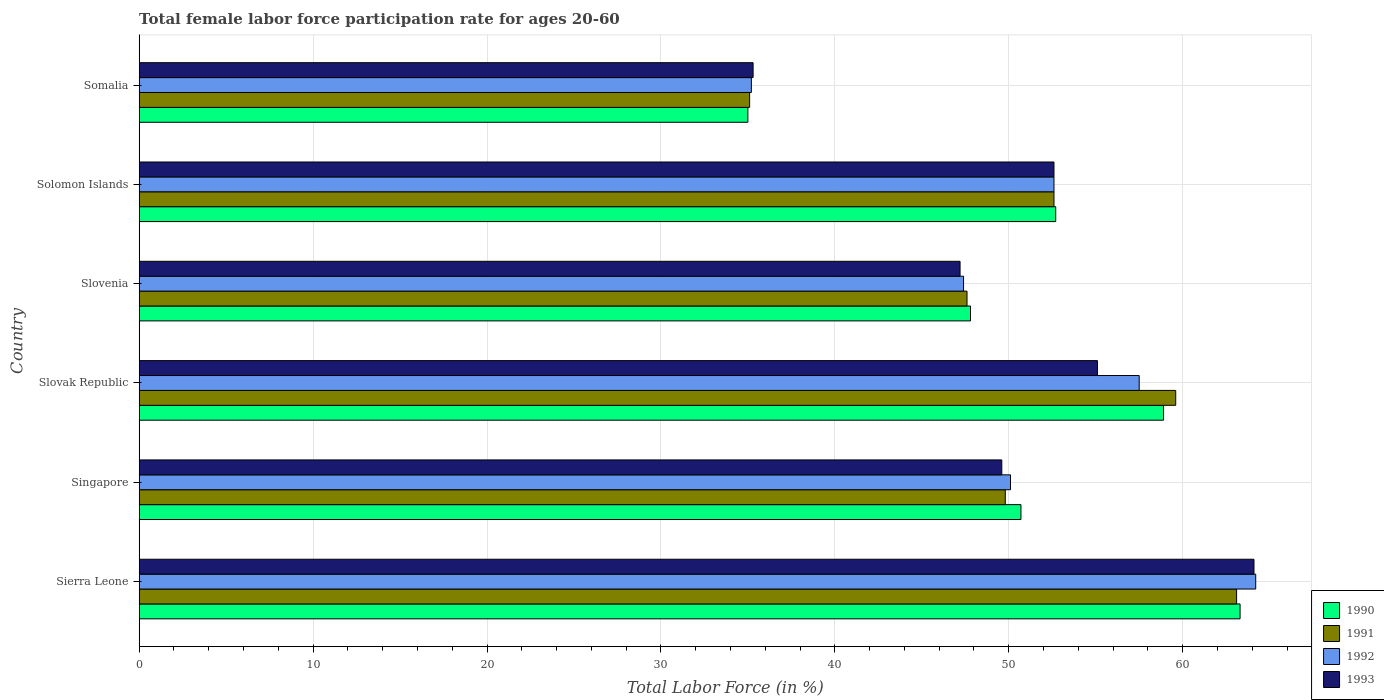How many different coloured bars are there?
Your answer should be very brief. 4. Are the number of bars per tick equal to the number of legend labels?
Make the answer very short. Yes. Are the number of bars on each tick of the Y-axis equal?
Offer a terse response. Yes. How many bars are there on the 2nd tick from the bottom?
Offer a very short reply. 4. What is the label of the 3rd group of bars from the top?
Your response must be concise. Slovenia. What is the female labor force participation rate in 1991 in Singapore?
Keep it short and to the point. 49.8. Across all countries, what is the maximum female labor force participation rate in 1993?
Provide a short and direct response. 64.1. Across all countries, what is the minimum female labor force participation rate in 1990?
Your answer should be very brief. 35. In which country was the female labor force participation rate in 1992 maximum?
Give a very brief answer. Sierra Leone. In which country was the female labor force participation rate in 1993 minimum?
Provide a succinct answer. Somalia. What is the total female labor force participation rate in 1993 in the graph?
Give a very brief answer. 303.9. What is the difference between the female labor force participation rate in 1992 in Slovenia and that in Somalia?
Make the answer very short. 12.2. What is the difference between the female labor force participation rate in 1992 in Slovenia and the female labor force participation rate in 1993 in Slovak Republic?
Provide a succinct answer. -7.7. What is the average female labor force participation rate in 1991 per country?
Ensure brevity in your answer.  51.3. What is the difference between the female labor force participation rate in 1993 and female labor force participation rate in 1991 in Slovenia?
Your answer should be compact. -0.4. What is the ratio of the female labor force participation rate in 1993 in Sierra Leone to that in Slovenia?
Your answer should be compact. 1.36. Is the female labor force participation rate in 1990 in Sierra Leone less than that in Somalia?
Make the answer very short. No. Is the difference between the female labor force participation rate in 1993 in Slovenia and Solomon Islands greater than the difference between the female labor force participation rate in 1991 in Slovenia and Solomon Islands?
Your answer should be very brief. No. What is the difference between the highest and the second highest female labor force participation rate in 1991?
Provide a short and direct response. 3.5. What is the difference between the highest and the lowest female labor force participation rate in 1992?
Give a very brief answer. 29. Is it the case that in every country, the sum of the female labor force participation rate in 1992 and female labor force participation rate in 1990 is greater than the sum of female labor force participation rate in 1991 and female labor force participation rate in 1993?
Offer a terse response. No. What does the 4th bar from the bottom in Slovak Republic represents?
Your answer should be very brief. 1993. Are all the bars in the graph horizontal?
Provide a short and direct response. Yes. How many countries are there in the graph?
Offer a very short reply. 6. What is the difference between two consecutive major ticks on the X-axis?
Your response must be concise. 10. Where does the legend appear in the graph?
Make the answer very short. Bottom right. How many legend labels are there?
Your response must be concise. 4. How are the legend labels stacked?
Provide a succinct answer. Vertical. What is the title of the graph?
Your answer should be compact. Total female labor force participation rate for ages 20-60. Does "1982" appear as one of the legend labels in the graph?
Provide a succinct answer. No. What is the label or title of the X-axis?
Give a very brief answer. Total Labor Force (in %). What is the label or title of the Y-axis?
Offer a very short reply. Country. What is the Total Labor Force (in %) in 1990 in Sierra Leone?
Give a very brief answer. 63.3. What is the Total Labor Force (in %) in 1991 in Sierra Leone?
Offer a very short reply. 63.1. What is the Total Labor Force (in %) of 1992 in Sierra Leone?
Make the answer very short. 64.2. What is the Total Labor Force (in %) in 1993 in Sierra Leone?
Your response must be concise. 64.1. What is the Total Labor Force (in %) in 1990 in Singapore?
Offer a very short reply. 50.7. What is the Total Labor Force (in %) in 1991 in Singapore?
Give a very brief answer. 49.8. What is the Total Labor Force (in %) in 1992 in Singapore?
Your answer should be compact. 50.1. What is the Total Labor Force (in %) in 1993 in Singapore?
Your answer should be compact. 49.6. What is the Total Labor Force (in %) in 1990 in Slovak Republic?
Your answer should be compact. 58.9. What is the Total Labor Force (in %) of 1991 in Slovak Republic?
Your answer should be very brief. 59.6. What is the Total Labor Force (in %) in 1992 in Slovak Republic?
Ensure brevity in your answer.  57.5. What is the Total Labor Force (in %) in 1993 in Slovak Republic?
Your answer should be very brief. 55.1. What is the Total Labor Force (in %) of 1990 in Slovenia?
Offer a terse response. 47.8. What is the Total Labor Force (in %) in 1991 in Slovenia?
Keep it short and to the point. 47.6. What is the Total Labor Force (in %) of 1992 in Slovenia?
Keep it short and to the point. 47.4. What is the Total Labor Force (in %) of 1993 in Slovenia?
Your answer should be very brief. 47.2. What is the Total Labor Force (in %) of 1990 in Solomon Islands?
Keep it short and to the point. 52.7. What is the Total Labor Force (in %) of 1991 in Solomon Islands?
Offer a terse response. 52.6. What is the Total Labor Force (in %) of 1992 in Solomon Islands?
Make the answer very short. 52.6. What is the Total Labor Force (in %) of 1993 in Solomon Islands?
Make the answer very short. 52.6. What is the Total Labor Force (in %) of 1991 in Somalia?
Ensure brevity in your answer.  35.1. What is the Total Labor Force (in %) in 1992 in Somalia?
Provide a succinct answer. 35.2. What is the Total Labor Force (in %) in 1993 in Somalia?
Your answer should be compact. 35.3. Across all countries, what is the maximum Total Labor Force (in %) in 1990?
Provide a short and direct response. 63.3. Across all countries, what is the maximum Total Labor Force (in %) of 1991?
Provide a succinct answer. 63.1. Across all countries, what is the maximum Total Labor Force (in %) of 1992?
Your answer should be very brief. 64.2. Across all countries, what is the maximum Total Labor Force (in %) of 1993?
Provide a short and direct response. 64.1. Across all countries, what is the minimum Total Labor Force (in %) in 1991?
Provide a succinct answer. 35.1. Across all countries, what is the minimum Total Labor Force (in %) of 1992?
Ensure brevity in your answer.  35.2. Across all countries, what is the minimum Total Labor Force (in %) in 1993?
Ensure brevity in your answer.  35.3. What is the total Total Labor Force (in %) of 1990 in the graph?
Offer a very short reply. 308.4. What is the total Total Labor Force (in %) of 1991 in the graph?
Ensure brevity in your answer.  307.8. What is the total Total Labor Force (in %) of 1992 in the graph?
Your answer should be compact. 307. What is the total Total Labor Force (in %) of 1993 in the graph?
Give a very brief answer. 303.9. What is the difference between the Total Labor Force (in %) in 1991 in Sierra Leone and that in Singapore?
Offer a very short reply. 13.3. What is the difference between the Total Labor Force (in %) in 1992 in Sierra Leone and that in Singapore?
Your response must be concise. 14.1. What is the difference between the Total Labor Force (in %) in 1993 in Sierra Leone and that in Singapore?
Your response must be concise. 14.5. What is the difference between the Total Labor Force (in %) of 1991 in Sierra Leone and that in Slovak Republic?
Ensure brevity in your answer.  3.5. What is the difference between the Total Labor Force (in %) in 1993 in Sierra Leone and that in Slovak Republic?
Your response must be concise. 9. What is the difference between the Total Labor Force (in %) of 1991 in Sierra Leone and that in Slovenia?
Offer a very short reply. 15.5. What is the difference between the Total Labor Force (in %) of 1992 in Sierra Leone and that in Slovenia?
Your answer should be very brief. 16.8. What is the difference between the Total Labor Force (in %) of 1993 in Sierra Leone and that in Slovenia?
Give a very brief answer. 16.9. What is the difference between the Total Labor Force (in %) in 1990 in Sierra Leone and that in Solomon Islands?
Offer a terse response. 10.6. What is the difference between the Total Labor Force (in %) of 1993 in Sierra Leone and that in Solomon Islands?
Ensure brevity in your answer.  11.5. What is the difference between the Total Labor Force (in %) of 1990 in Sierra Leone and that in Somalia?
Your answer should be very brief. 28.3. What is the difference between the Total Labor Force (in %) in 1993 in Sierra Leone and that in Somalia?
Give a very brief answer. 28.8. What is the difference between the Total Labor Force (in %) in 1990 in Singapore and that in Slovak Republic?
Keep it short and to the point. -8.2. What is the difference between the Total Labor Force (in %) of 1992 in Singapore and that in Slovak Republic?
Offer a very short reply. -7.4. What is the difference between the Total Labor Force (in %) of 1993 in Singapore and that in Slovak Republic?
Your answer should be compact. -5.5. What is the difference between the Total Labor Force (in %) in 1990 in Singapore and that in Slovenia?
Keep it short and to the point. 2.9. What is the difference between the Total Labor Force (in %) of 1991 in Singapore and that in Slovenia?
Keep it short and to the point. 2.2. What is the difference between the Total Labor Force (in %) in 1992 in Singapore and that in Slovenia?
Provide a succinct answer. 2.7. What is the difference between the Total Labor Force (in %) of 1993 in Singapore and that in Slovenia?
Ensure brevity in your answer.  2.4. What is the difference between the Total Labor Force (in %) of 1993 in Singapore and that in Solomon Islands?
Keep it short and to the point. -3. What is the difference between the Total Labor Force (in %) of 1991 in Singapore and that in Somalia?
Ensure brevity in your answer.  14.7. What is the difference between the Total Labor Force (in %) in 1992 in Singapore and that in Somalia?
Offer a very short reply. 14.9. What is the difference between the Total Labor Force (in %) of 1993 in Singapore and that in Somalia?
Provide a succinct answer. 14.3. What is the difference between the Total Labor Force (in %) of 1991 in Slovak Republic and that in Slovenia?
Offer a terse response. 12. What is the difference between the Total Labor Force (in %) in 1991 in Slovak Republic and that in Solomon Islands?
Make the answer very short. 7. What is the difference between the Total Labor Force (in %) in 1990 in Slovak Republic and that in Somalia?
Offer a very short reply. 23.9. What is the difference between the Total Labor Force (in %) in 1991 in Slovak Republic and that in Somalia?
Provide a short and direct response. 24.5. What is the difference between the Total Labor Force (in %) of 1992 in Slovak Republic and that in Somalia?
Offer a terse response. 22.3. What is the difference between the Total Labor Force (in %) of 1993 in Slovak Republic and that in Somalia?
Your answer should be very brief. 19.8. What is the difference between the Total Labor Force (in %) in 1992 in Slovenia and that in Solomon Islands?
Keep it short and to the point. -5.2. What is the difference between the Total Labor Force (in %) in 1993 in Slovenia and that in Solomon Islands?
Keep it short and to the point. -5.4. What is the difference between the Total Labor Force (in %) of 1991 in Slovenia and that in Somalia?
Make the answer very short. 12.5. What is the difference between the Total Labor Force (in %) of 1992 in Slovenia and that in Somalia?
Provide a succinct answer. 12.2. What is the difference between the Total Labor Force (in %) in 1993 in Slovenia and that in Somalia?
Provide a short and direct response. 11.9. What is the difference between the Total Labor Force (in %) of 1990 in Solomon Islands and that in Somalia?
Provide a succinct answer. 17.7. What is the difference between the Total Labor Force (in %) of 1991 in Solomon Islands and that in Somalia?
Offer a very short reply. 17.5. What is the difference between the Total Labor Force (in %) of 1993 in Solomon Islands and that in Somalia?
Make the answer very short. 17.3. What is the difference between the Total Labor Force (in %) of 1990 in Sierra Leone and the Total Labor Force (in %) of 1991 in Singapore?
Give a very brief answer. 13.5. What is the difference between the Total Labor Force (in %) in 1991 in Sierra Leone and the Total Labor Force (in %) in 1993 in Singapore?
Provide a succinct answer. 13.5. What is the difference between the Total Labor Force (in %) of 1992 in Sierra Leone and the Total Labor Force (in %) of 1993 in Singapore?
Provide a succinct answer. 14.6. What is the difference between the Total Labor Force (in %) in 1990 in Sierra Leone and the Total Labor Force (in %) in 1992 in Slovak Republic?
Offer a terse response. 5.8. What is the difference between the Total Labor Force (in %) in 1990 in Sierra Leone and the Total Labor Force (in %) in 1993 in Slovak Republic?
Provide a short and direct response. 8.2. What is the difference between the Total Labor Force (in %) of 1991 in Sierra Leone and the Total Labor Force (in %) of 1992 in Slovak Republic?
Give a very brief answer. 5.6. What is the difference between the Total Labor Force (in %) of 1991 in Sierra Leone and the Total Labor Force (in %) of 1993 in Slovak Republic?
Your answer should be very brief. 8. What is the difference between the Total Labor Force (in %) of 1990 in Sierra Leone and the Total Labor Force (in %) of 1992 in Slovenia?
Keep it short and to the point. 15.9. What is the difference between the Total Labor Force (in %) of 1992 in Sierra Leone and the Total Labor Force (in %) of 1993 in Slovenia?
Keep it short and to the point. 17. What is the difference between the Total Labor Force (in %) of 1990 in Sierra Leone and the Total Labor Force (in %) of 1991 in Solomon Islands?
Provide a short and direct response. 10.7. What is the difference between the Total Labor Force (in %) of 1991 in Sierra Leone and the Total Labor Force (in %) of 1992 in Solomon Islands?
Provide a succinct answer. 10.5. What is the difference between the Total Labor Force (in %) of 1991 in Sierra Leone and the Total Labor Force (in %) of 1993 in Solomon Islands?
Ensure brevity in your answer.  10.5. What is the difference between the Total Labor Force (in %) of 1992 in Sierra Leone and the Total Labor Force (in %) of 1993 in Solomon Islands?
Your answer should be compact. 11.6. What is the difference between the Total Labor Force (in %) in 1990 in Sierra Leone and the Total Labor Force (in %) in 1991 in Somalia?
Keep it short and to the point. 28.2. What is the difference between the Total Labor Force (in %) of 1990 in Sierra Leone and the Total Labor Force (in %) of 1992 in Somalia?
Your answer should be very brief. 28.1. What is the difference between the Total Labor Force (in %) of 1990 in Sierra Leone and the Total Labor Force (in %) of 1993 in Somalia?
Your answer should be compact. 28. What is the difference between the Total Labor Force (in %) of 1991 in Sierra Leone and the Total Labor Force (in %) of 1992 in Somalia?
Provide a short and direct response. 27.9. What is the difference between the Total Labor Force (in %) in 1991 in Sierra Leone and the Total Labor Force (in %) in 1993 in Somalia?
Your answer should be compact. 27.8. What is the difference between the Total Labor Force (in %) in 1992 in Sierra Leone and the Total Labor Force (in %) in 1993 in Somalia?
Give a very brief answer. 28.9. What is the difference between the Total Labor Force (in %) in 1990 in Singapore and the Total Labor Force (in %) in 1992 in Slovak Republic?
Keep it short and to the point. -6.8. What is the difference between the Total Labor Force (in %) in 1991 in Singapore and the Total Labor Force (in %) in 1993 in Slovak Republic?
Give a very brief answer. -5.3. What is the difference between the Total Labor Force (in %) of 1991 in Singapore and the Total Labor Force (in %) of 1993 in Slovenia?
Provide a succinct answer. 2.6. What is the difference between the Total Labor Force (in %) in 1990 in Singapore and the Total Labor Force (in %) in 1993 in Solomon Islands?
Ensure brevity in your answer.  -1.9. What is the difference between the Total Labor Force (in %) of 1991 in Singapore and the Total Labor Force (in %) of 1992 in Solomon Islands?
Provide a short and direct response. -2.8. What is the difference between the Total Labor Force (in %) of 1991 in Singapore and the Total Labor Force (in %) of 1993 in Solomon Islands?
Your answer should be very brief. -2.8. What is the difference between the Total Labor Force (in %) in 1992 in Singapore and the Total Labor Force (in %) in 1993 in Solomon Islands?
Ensure brevity in your answer.  -2.5. What is the difference between the Total Labor Force (in %) in 1990 in Singapore and the Total Labor Force (in %) in 1991 in Somalia?
Make the answer very short. 15.6. What is the difference between the Total Labor Force (in %) in 1992 in Singapore and the Total Labor Force (in %) in 1993 in Somalia?
Offer a terse response. 14.8. What is the difference between the Total Labor Force (in %) in 1990 in Slovak Republic and the Total Labor Force (in %) in 1992 in Slovenia?
Your answer should be compact. 11.5. What is the difference between the Total Labor Force (in %) in 1990 in Slovak Republic and the Total Labor Force (in %) in 1993 in Slovenia?
Ensure brevity in your answer.  11.7. What is the difference between the Total Labor Force (in %) in 1991 in Slovak Republic and the Total Labor Force (in %) in 1993 in Slovenia?
Provide a succinct answer. 12.4. What is the difference between the Total Labor Force (in %) of 1990 in Slovak Republic and the Total Labor Force (in %) of 1991 in Solomon Islands?
Ensure brevity in your answer.  6.3. What is the difference between the Total Labor Force (in %) of 1990 in Slovak Republic and the Total Labor Force (in %) of 1992 in Solomon Islands?
Offer a terse response. 6.3. What is the difference between the Total Labor Force (in %) in 1990 in Slovak Republic and the Total Labor Force (in %) in 1993 in Solomon Islands?
Offer a terse response. 6.3. What is the difference between the Total Labor Force (in %) of 1991 in Slovak Republic and the Total Labor Force (in %) of 1992 in Solomon Islands?
Your answer should be compact. 7. What is the difference between the Total Labor Force (in %) of 1991 in Slovak Republic and the Total Labor Force (in %) of 1993 in Solomon Islands?
Your response must be concise. 7. What is the difference between the Total Labor Force (in %) of 1992 in Slovak Republic and the Total Labor Force (in %) of 1993 in Solomon Islands?
Provide a short and direct response. 4.9. What is the difference between the Total Labor Force (in %) in 1990 in Slovak Republic and the Total Labor Force (in %) in 1991 in Somalia?
Offer a terse response. 23.8. What is the difference between the Total Labor Force (in %) in 1990 in Slovak Republic and the Total Labor Force (in %) in 1992 in Somalia?
Provide a short and direct response. 23.7. What is the difference between the Total Labor Force (in %) in 1990 in Slovak Republic and the Total Labor Force (in %) in 1993 in Somalia?
Give a very brief answer. 23.6. What is the difference between the Total Labor Force (in %) in 1991 in Slovak Republic and the Total Labor Force (in %) in 1992 in Somalia?
Ensure brevity in your answer.  24.4. What is the difference between the Total Labor Force (in %) in 1991 in Slovak Republic and the Total Labor Force (in %) in 1993 in Somalia?
Keep it short and to the point. 24.3. What is the difference between the Total Labor Force (in %) of 1992 in Slovak Republic and the Total Labor Force (in %) of 1993 in Somalia?
Offer a terse response. 22.2. What is the difference between the Total Labor Force (in %) of 1990 in Slovenia and the Total Labor Force (in %) of 1991 in Solomon Islands?
Your answer should be very brief. -4.8. What is the difference between the Total Labor Force (in %) of 1991 in Slovenia and the Total Labor Force (in %) of 1992 in Solomon Islands?
Your response must be concise. -5. What is the difference between the Total Labor Force (in %) of 1990 in Slovenia and the Total Labor Force (in %) of 1993 in Somalia?
Your answer should be compact. 12.5. What is the difference between the Total Labor Force (in %) of 1991 in Slovenia and the Total Labor Force (in %) of 1993 in Somalia?
Offer a very short reply. 12.3. What is the difference between the Total Labor Force (in %) of 1990 in Solomon Islands and the Total Labor Force (in %) of 1991 in Somalia?
Make the answer very short. 17.6. What is the difference between the Total Labor Force (in %) in 1990 in Solomon Islands and the Total Labor Force (in %) in 1993 in Somalia?
Provide a succinct answer. 17.4. What is the difference between the Total Labor Force (in %) of 1991 in Solomon Islands and the Total Labor Force (in %) of 1992 in Somalia?
Ensure brevity in your answer.  17.4. What is the difference between the Total Labor Force (in %) of 1991 in Solomon Islands and the Total Labor Force (in %) of 1993 in Somalia?
Your answer should be compact. 17.3. What is the difference between the Total Labor Force (in %) in 1992 in Solomon Islands and the Total Labor Force (in %) in 1993 in Somalia?
Keep it short and to the point. 17.3. What is the average Total Labor Force (in %) of 1990 per country?
Your answer should be very brief. 51.4. What is the average Total Labor Force (in %) of 1991 per country?
Make the answer very short. 51.3. What is the average Total Labor Force (in %) of 1992 per country?
Keep it short and to the point. 51.17. What is the average Total Labor Force (in %) of 1993 per country?
Your answer should be compact. 50.65. What is the difference between the Total Labor Force (in %) in 1990 and Total Labor Force (in %) in 1991 in Sierra Leone?
Offer a terse response. 0.2. What is the difference between the Total Labor Force (in %) of 1990 and Total Labor Force (in %) of 1992 in Sierra Leone?
Provide a succinct answer. -0.9. What is the difference between the Total Labor Force (in %) of 1990 and Total Labor Force (in %) of 1993 in Sierra Leone?
Provide a short and direct response. -0.8. What is the difference between the Total Labor Force (in %) of 1991 and Total Labor Force (in %) of 1992 in Sierra Leone?
Give a very brief answer. -1.1. What is the difference between the Total Labor Force (in %) in 1991 and Total Labor Force (in %) in 1993 in Sierra Leone?
Give a very brief answer. -1. What is the difference between the Total Labor Force (in %) in 1990 and Total Labor Force (in %) in 1991 in Singapore?
Ensure brevity in your answer.  0.9. What is the difference between the Total Labor Force (in %) of 1990 and Total Labor Force (in %) of 1992 in Singapore?
Ensure brevity in your answer.  0.6. What is the difference between the Total Labor Force (in %) of 1990 and Total Labor Force (in %) of 1993 in Singapore?
Offer a terse response. 1.1. What is the difference between the Total Labor Force (in %) of 1990 and Total Labor Force (in %) of 1991 in Slovak Republic?
Your response must be concise. -0.7. What is the difference between the Total Labor Force (in %) of 1991 and Total Labor Force (in %) of 1992 in Slovak Republic?
Offer a very short reply. 2.1. What is the difference between the Total Labor Force (in %) of 1990 and Total Labor Force (in %) of 1991 in Slovenia?
Offer a very short reply. 0.2. What is the difference between the Total Labor Force (in %) in 1990 and Total Labor Force (in %) in 1993 in Slovenia?
Provide a short and direct response. 0.6. What is the difference between the Total Labor Force (in %) of 1990 and Total Labor Force (in %) of 1991 in Solomon Islands?
Your answer should be compact. 0.1. What is the difference between the Total Labor Force (in %) of 1990 and Total Labor Force (in %) of 1993 in Solomon Islands?
Offer a very short reply. 0.1. What is the difference between the Total Labor Force (in %) in 1991 and Total Labor Force (in %) in 1993 in Solomon Islands?
Provide a succinct answer. 0. What is the difference between the Total Labor Force (in %) in 1990 and Total Labor Force (in %) in 1991 in Somalia?
Provide a succinct answer. -0.1. What is the difference between the Total Labor Force (in %) of 1990 and Total Labor Force (in %) of 1993 in Somalia?
Offer a terse response. -0.3. What is the difference between the Total Labor Force (in %) of 1991 and Total Labor Force (in %) of 1993 in Somalia?
Give a very brief answer. -0.2. What is the difference between the Total Labor Force (in %) in 1992 and Total Labor Force (in %) in 1993 in Somalia?
Make the answer very short. -0.1. What is the ratio of the Total Labor Force (in %) of 1990 in Sierra Leone to that in Singapore?
Your answer should be compact. 1.25. What is the ratio of the Total Labor Force (in %) in 1991 in Sierra Leone to that in Singapore?
Offer a very short reply. 1.27. What is the ratio of the Total Labor Force (in %) in 1992 in Sierra Leone to that in Singapore?
Offer a very short reply. 1.28. What is the ratio of the Total Labor Force (in %) in 1993 in Sierra Leone to that in Singapore?
Your answer should be very brief. 1.29. What is the ratio of the Total Labor Force (in %) in 1990 in Sierra Leone to that in Slovak Republic?
Ensure brevity in your answer.  1.07. What is the ratio of the Total Labor Force (in %) in 1991 in Sierra Leone to that in Slovak Republic?
Your answer should be very brief. 1.06. What is the ratio of the Total Labor Force (in %) in 1992 in Sierra Leone to that in Slovak Republic?
Provide a succinct answer. 1.12. What is the ratio of the Total Labor Force (in %) in 1993 in Sierra Leone to that in Slovak Republic?
Keep it short and to the point. 1.16. What is the ratio of the Total Labor Force (in %) of 1990 in Sierra Leone to that in Slovenia?
Offer a terse response. 1.32. What is the ratio of the Total Labor Force (in %) in 1991 in Sierra Leone to that in Slovenia?
Provide a short and direct response. 1.33. What is the ratio of the Total Labor Force (in %) in 1992 in Sierra Leone to that in Slovenia?
Provide a short and direct response. 1.35. What is the ratio of the Total Labor Force (in %) in 1993 in Sierra Leone to that in Slovenia?
Provide a short and direct response. 1.36. What is the ratio of the Total Labor Force (in %) in 1990 in Sierra Leone to that in Solomon Islands?
Give a very brief answer. 1.2. What is the ratio of the Total Labor Force (in %) in 1991 in Sierra Leone to that in Solomon Islands?
Give a very brief answer. 1.2. What is the ratio of the Total Labor Force (in %) of 1992 in Sierra Leone to that in Solomon Islands?
Ensure brevity in your answer.  1.22. What is the ratio of the Total Labor Force (in %) of 1993 in Sierra Leone to that in Solomon Islands?
Your answer should be compact. 1.22. What is the ratio of the Total Labor Force (in %) in 1990 in Sierra Leone to that in Somalia?
Provide a succinct answer. 1.81. What is the ratio of the Total Labor Force (in %) of 1991 in Sierra Leone to that in Somalia?
Your answer should be very brief. 1.8. What is the ratio of the Total Labor Force (in %) in 1992 in Sierra Leone to that in Somalia?
Provide a succinct answer. 1.82. What is the ratio of the Total Labor Force (in %) in 1993 in Sierra Leone to that in Somalia?
Ensure brevity in your answer.  1.82. What is the ratio of the Total Labor Force (in %) in 1990 in Singapore to that in Slovak Republic?
Your answer should be compact. 0.86. What is the ratio of the Total Labor Force (in %) of 1991 in Singapore to that in Slovak Republic?
Your response must be concise. 0.84. What is the ratio of the Total Labor Force (in %) in 1992 in Singapore to that in Slovak Republic?
Make the answer very short. 0.87. What is the ratio of the Total Labor Force (in %) of 1993 in Singapore to that in Slovak Republic?
Offer a very short reply. 0.9. What is the ratio of the Total Labor Force (in %) of 1990 in Singapore to that in Slovenia?
Offer a very short reply. 1.06. What is the ratio of the Total Labor Force (in %) in 1991 in Singapore to that in Slovenia?
Your answer should be compact. 1.05. What is the ratio of the Total Labor Force (in %) of 1992 in Singapore to that in Slovenia?
Keep it short and to the point. 1.06. What is the ratio of the Total Labor Force (in %) of 1993 in Singapore to that in Slovenia?
Offer a terse response. 1.05. What is the ratio of the Total Labor Force (in %) of 1991 in Singapore to that in Solomon Islands?
Your response must be concise. 0.95. What is the ratio of the Total Labor Force (in %) in 1992 in Singapore to that in Solomon Islands?
Keep it short and to the point. 0.95. What is the ratio of the Total Labor Force (in %) in 1993 in Singapore to that in Solomon Islands?
Ensure brevity in your answer.  0.94. What is the ratio of the Total Labor Force (in %) of 1990 in Singapore to that in Somalia?
Your response must be concise. 1.45. What is the ratio of the Total Labor Force (in %) in 1991 in Singapore to that in Somalia?
Your answer should be very brief. 1.42. What is the ratio of the Total Labor Force (in %) in 1992 in Singapore to that in Somalia?
Give a very brief answer. 1.42. What is the ratio of the Total Labor Force (in %) of 1993 in Singapore to that in Somalia?
Give a very brief answer. 1.41. What is the ratio of the Total Labor Force (in %) of 1990 in Slovak Republic to that in Slovenia?
Your response must be concise. 1.23. What is the ratio of the Total Labor Force (in %) in 1991 in Slovak Republic to that in Slovenia?
Your answer should be compact. 1.25. What is the ratio of the Total Labor Force (in %) in 1992 in Slovak Republic to that in Slovenia?
Offer a terse response. 1.21. What is the ratio of the Total Labor Force (in %) of 1993 in Slovak Republic to that in Slovenia?
Your answer should be very brief. 1.17. What is the ratio of the Total Labor Force (in %) in 1990 in Slovak Republic to that in Solomon Islands?
Provide a short and direct response. 1.12. What is the ratio of the Total Labor Force (in %) of 1991 in Slovak Republic to that in Solomon Islands?
Offer a very short reply. 1.13. What is the ratio of the Total Labor Force (in %) in 1992 in Slovak Republic to that in Solomon Islands?
Ensure brevity in your answer.  1.09. What is the ratio of the Total Labor Force (in %) of 1993 in Slovak Republic to that in Solomon Islands?
Your answer should be compact. 1.05. What is the ratio of the Total Labor Force (in %) in 1990 in Slovak Republic to that in Somalia?
Provide a succinct answer. 1.68. What is the ratio of the Total Labor Force (in %) of 1991 in Slovak Republic to that in Somalia?
Your answer should be very brief. 1.7. What is the ratio of the Total Labor Force (in %) in 1992 in Slovak Republic to that in Somalia?
Offer a terse response. 1.63. What is the ratio of the Total Labor Force (in %) of 1993 in Slovak Republic to that in Somalia?
Keep it short and to the point. 1.56. What is the ratio of the Total Labor Force (in %) of 1990 in Slovenia to that in Solomon Islands?
Make the answer very short. 0.91. What is the ratio of the Total Labor Force (in %) in 1991 in Slovenia to that in Solomon Islands?
Keep it short and to the point. 0.9. What is the ratio of the Total Labor Force (in %) in 1992 in Slovenia to that in Solomon Islands?
Your response must be concise. 0.9. What is the ratio of the Total Labor Force (in %) of 1993 in Slovenia to that in Solomon Islands?
Your answer should be compact. 0.9. What is the ratio of the Total Labor Force (in %) of 1990 in Slovenia to that in Somalia?
Ensure brevity in your answer.  1.37. What is the ratio of the Total Labor Force (in %) of 1991 in Slovenia to that in Somalia?
Your answer should be very brief. 1.36. What is the ratio of the Total Labor Force (in %) in 1992 in Slovenia to that in Somalia?
Provide a short and direct response. 1.35. What is the ratio of the Total Labor Force (in %) in 1993 in Slovenia to that in Somalia?
Ensure brevity in your answer.  1.34. What is the ratio of the Total Labor Force (in %) in 1990 in Solomon Islands to that in Somalia?
Offer a very short reply. 1.51. What is the ratio of the Total Labor Force (in %) in 1991 in Solomon Islands to that in Somalia?
Provide a succinct answer. 1.5. What is the ratio of the Total Labor Force (in %) in 1992 in Solomon Islands to that in Somalia?
Offer a terse response. 1.49. What is the ratio of the Total Labor Force (in %) in 1993 in Solomon Islands to that in Somalia?
Provide a succinct answer. 1.49. What is the difference between the highest and the second highest Total Labor Force (in %) of 1990?
Provide a succinct answer. 4.4. What is the difference between the highest and the second highest Total Labor Force (in %) in 1991?
Offer a very short reply. 3.5. What is the difference between the highest and the second highest Total Labor Force (in %) in 1992?
Offer a very short reply. 6.7. What is the difference between the highest and the second highest Total Labor Force (in %) of 1993?
Make the answer very short. 9. What is the difference between the highest and the lowest Total Labor Force (in %) of 1990?
Provide a short and direct response. 28.3. What is the difference between the highest and the lowest Total Labor Force (in %) of 1991?
Your answer should be very brief. 28. What is the difference between the highest and the lowest Total Labor Force (in %) of 1992?
Offer a very short reply. 29. What is the difference between the highest and the lowest Total Labor Force (in %) of 1993?
Your response must be concise. 28.8. 